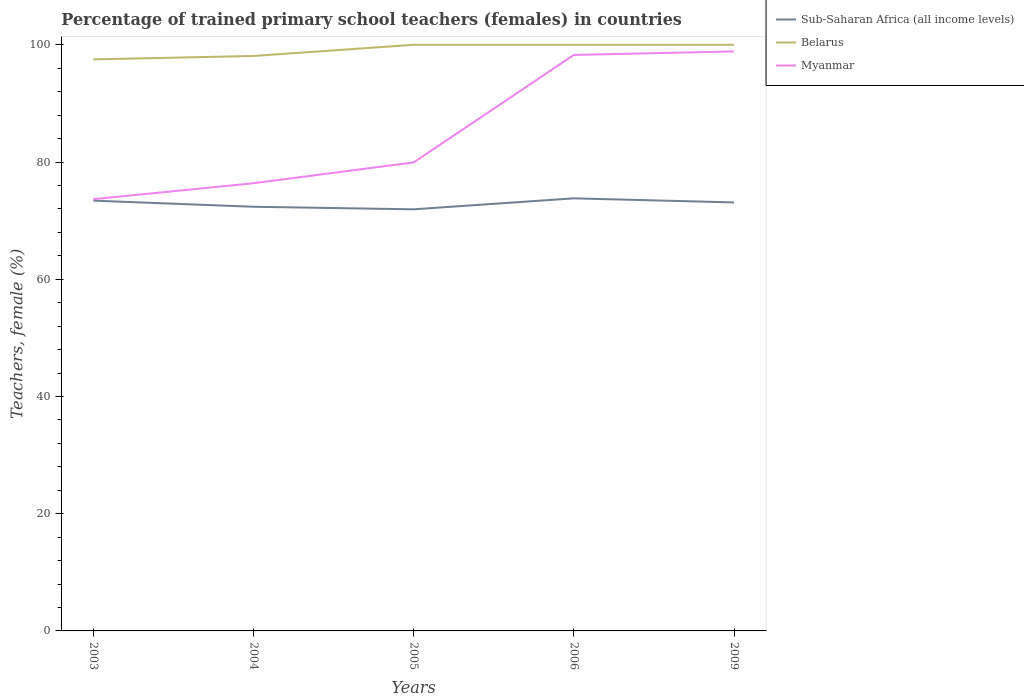How many different coloured lines are there?
Offer a terse response. 3. Is the number of lines equal to the number of legend labels?
Offer a very short reply. Yes. Across all years, what is the maximum percentage of trained primary school teachers (females) in Belarus?
Offer a terse response. 97.51. In which year was the percentage of trained primary school teachers (females) in Myanmar maximum?
Offer a terse response. 2003. What is the total percentage of trained primary school teachers (females) in Sub-Saharan Africa (all income levels) in the graph?
Your answer should be very brief. 1.48. What is the difference between the highest and the second highest percentage of trained primary school teachers (females) in Sub-Saharan Africa (all income levels)?
Your response must be concise. 1.87. What is the difference between the highest and the lowest percentage of trained primary school teachers (females) in Belarus?
Keep it short and to the point. 3. How many years are there in the graph?
Give a very brief answer. 5. What is the difference between two consecutive major ticks on the Y-axis?
Ensure brevity in your answer.  20. Where does the legend appear in the graph?
Keep it short and to the point. Top right. What is the title of the graph?
Keep it short and to the point. Percentage of trained primary school teachers (females) in countries. What is the label or title of the Y-axis?
Keep it short and to the point. Teachers, female (%). What is the Teachers, female (%) of Sub-Saharan Africa (all income levels) in 2003?
Offer a terse response. 73.41. What is the Teachers, female (%) in Belarus in 2003?
Offer a very short reply. 97.51. What is the Teachers, female (%) of Myanmar in 2003?
Offer a very short reply. 73.66. What is the Teachers, female (%) of Sub-Saharan Africa (all income levels) in 2004?
Keep it short and to the point. 72.37. What is the Teachers, female (%) in Belarus in 2004?
Keep it short and to the point. 98.1. What is the Teachers, female (%) of Myanmar in 2004?
Provide a short and direct response. 76.38. What is the Teachers, female (%) in Sub-Saharan Africa (all income levels) in 2005?
Your answer should be compact. 71.93. What is the Teachers, female (%) in Belarus in 2005?
Ensure brevity in your answer.  100. What is the Teachers, female (%) in Myanmar in 2005?
Offer a very short reply. 79.94. What is the Teachers, female (%) in Sub-Saharan Africa (all income levels) in 2006?
Keep it short and to the point. 73.81. What is the Teachers, female (%) in Belarus in 2006?
Give a very brief answer. 100. What is the Teachers, female (%) of Myanmar in 2006?
Keep it short and to the point. 98.27. What is the Teachers, female (%) in Sub-Saharan Africa (all income levels) in 2009?
Offer a terse response. 73.1. What is the Teachers, female (%) of Myanmar in 2009?
Ensure brevity in your answer.  98.87. Across all years, what is the maximum Teachers, female (%) in Sub-Saharan Africa (all income levels)?
Provide a succinct answer. 73.81. Across all years, what is the maximum Teachers, female (%) in Belarus?
Your answer should be compact. 100. Across all years, what is the maximum Teachers, female (%) in Myanmar?
Give a very brief answer. 98.87. Across all years, what is the minimum Teachers, female (%) in Sub-Saharan Africa (all income levels)?
Provide a succinct answer. 71.93. Across all years, what is the minimum Teachers, female (%) in Belarus?
Ensure brevity in your answer.  97.51. Across all years, what is the minimum Teachers, female (%) of Myanmar?
Provide a short and direct response. 73.66. What is the total Teachers, female (%) of Sub-Saharan Africa (all income levels) in the graph?
Give a very brief answer. 364.62. What is the total Teachers, female (%) in Belarus in the graph?
Provide a short and direct response. 495.61. What is the total Teachers, female (%) of Myanmar in the graph?
Make the answer very short. 427.13. What is the difference between the Teachers, female (%) of Sub-Saharan Africa (all income levels) in 2003 and that in 2004?
Provide a short and direct response. 1.05. What is the difference between the Teachers, female (%) of Belarus in 2003 and that in 2004?
Provide a succinct answer. -0.58. What is the difference between the Teachers, female (%) in Myanmar in 2003 and that in 2004?
Provide a short and direct response. -2.72. What is the difference between the Teachers, female (%) in Sub-Saharan Africa (all income levels) in 2003 and that in 2005?
Make the answer very short. 1.48. What is the difference between the Teachers, female (%) in Belarus in 2003 and that in 2005?
Your answer should be very brief. -2.49. What is the difference between the Teachers, female (%) in Myanmar in 2003 and that in 2005?
Give a very brief answer. -6.28. What is the difference between the Teachers, female (%) in Sub-Saharan Africa (all income levels) in 2003 and that in 2006?
Your answer should be very brief. -0.39. What is the difference between the Teachers, female (%) of Belarus in 2003 and that in 2006?
Provide a succinct answer. -2.49. What is the difference between the Teachers, female (%) of Myanmar in 2003 and that in 2006?
Provide a succinct answer. -24.61. What is the difference between the Teachers, female (%) in Sub-Saharan Africa (all income levels) in 2003 and that in 2009?
Make the answer very short. 0.31. What is the difference between the Teachers, female (%) of Belarus in 2003 and that in 2009?
Provide a short and direct response. -2.49. What is the difference between the Teachers, female (%) in Myanmar in 2003 and that in 2009?
Your response must be concise. -25.2. What is the difference between the Teachers, female (%) in Sub-Saharan Africa (all income levels) in 2004 and that in 2005?
Provide a succinct answer. 0.43. What is the difference between the Teachers, female (%) in Belarus in 2004 and that in 2005?
Ensure brevity in your answer.  -1.9. What is the difference between the Teachers, female (%) of Myanmar in 2004 and that in 2005?
Offer a terse response. -3.56. What is the difference between the Teachers, female (%) in Sub-Saharan Africa (all income levels) in 2004 and that in 2006?
Ensure brevity in your answer.  -1.44. What is the difference between the Teachers, female (%) of Belarus in 2004 and that in 2006?
Provide a succinct answer. -1.9. What is the difference between the Teachers, female (%) of Myanmar in 2004 and that in 2006?
Your answer should be compact. -21.89. What is the difference between the Teachers, female (%) in Sub-Saharan Africa (all income levels) in 2004 and that in 2009?
Your answer should be very brief. -0.74. What is the difference between the Teachers, female (%) in Belarus in 2004 and that in 2009?
Provide a short and direct response. -1.9. What is the difference between the Teachers, female (%) in Myanmar in 2004 and that in 2009?
Provide a short and direct response. -22.49. What is the difference between the Teachers, female (%) in Sub-Saharan Africa (all income levels) in 2005 and that in 2006?
Make the answer very short. -1.87. What is the difference between the Teachers, female (%) of Belarus in 2005 and that in 2006?
Keep it short and to the point. 0. What is the difference between the Teachers, female (%) in Myanmar in 2005 and that in 2006?
Give a very brief answer. -18.33. What is the difference between the Teachers, female (%) of Sub-Saharan Africa (all income levels) in 2005 and that in 2009?
Provide a succinct answer. -1.17. What is the difference between the Teachers, female (%) of Belarus in 2005 and that in 2009?
Your response must be concise. 0. What is the difference between the Teachers, female (%) of Myanmar in 2005 and that in 2009?
Provide a succinct answer. -18.93. What is the difference between the Teachers, female (%) of Sub-Saharan Africa (all income levels) in 2006 and that in 2009?
Your response must be concise. 0.7. What is the difference between the Teachers, female (%) of Myanmar in 2006 and that in 2009?
Provide a succinct answer. -0.6. What is the difference between the Teachers, female (%) of Sub-Saharan Africa (all income levels) in 2003 and the Teachers, female (%) of Belarus in 2004?
Make the answer very short. -24.68. What is the difference between the Teachers, female (%) of Sub-Saharan Africa (all income levels) in 2003 and the Teachers, female (%) of Myanmar in 2004?
Your response must be concise. -2.97. What is the difference between the Teachers, female (%) of Belarus in 2003 and the Teachers, female (%) of Myanmar in 2004?
Offer a terse response. 21.13. What is the difference between the Teachers, female (%) in Sub-Saharan Africa (all income levels) in 2003 and the Teachers, female (%) in Belarus in 2005?
Provide a succinct answer. -26.59. What is the difference between the Teachers, female (%) of Sub-Saharan Africa (all income levels) in 2003 and the Teachers, female (%) of Myanmar in 2005?
Provide a succinct answer. -6.53. What is the difference between the Teachers, female (%) of Belarus in 2003 and the Teachers, female (%) of Myanmar in 2005?
Provide a short and direct response. 17.57. What is the difference between the Teachers, female (%) of Sub-Saharan Africa (all income levels) in 2003 and the Teachers, female (%) of Belarus in 2006?
Make the answer very short. -26.59. What is the difference between the Teachers, female (%) in Sub-Saharan Africa (all income levels) in 2003 and the Teachers, female (%) in Myanmar in 2006?
Offer a terse response. -24.86. What is the difference between the Teachers, female (%) of Belarus in 2003 and the Teachers, female (%) of Myanmar in 2006?
Your response must be concise. -0.76. What is the difference between the Teachers, female (%) of Sub-Saharan Africa (all income levels) in 2003 and the Teachers, female (%) of Belarus in 2009?
Provide a short and direct response. -26.59. What is the difference between the Teachers, female (%) of Sub-Saharan Africa (all income levels) in 2003 and the Teachers, female (%) of Myanmar in 2009?
Your answer should be very brief. -25.46. What is the difference between the Teachers, female (%) in Belarus in 2003 and the Teachers, female (%) in Myanmar in 2009?
Keep it short and to the point. -1.36. What is the difference between the Teachers, female (%) of Sub-Saharan Africa (all income levels) in 2004 and the Teachers, female (%) of Belarus in 2005?
Your response must be concise. -27.63. What is the difference between the Teachers, female (%) in Sub-Saharan Africa (all income levels) in 2004 and the Teachers, female (%) in Myanmar in 2005?
Your answer should be compact. -7.57. What is the difference between the Teachers, female (%) in Belarus in 2004 and the Teachers, female (%) in Myanmar in 2005?
Offer a terse response. 18.16. What is the difference between the Teachers, female (%) of Sub-Saharan Africa (all income levels) in 2004 and the Teachers, female (%) of Belarus in 2006?
Your response must be concise. -27.63. What is the difference between the Teachers, female (%) in Sub-Saharan Africa (all income levels) in 2004 and the Teachers, female (%) in Myanmar in 2006?
Your answer should be very brief. -25.91. What is the difference between the Teachers, female (%) of Belarus in 2004 and the Teachers, female (%) of Myanmar in 2006?
Your response must be concise. -0.18. What is the difference between the Teachers, female (%) of Sub-Saharan Africa (all income levels) in 2004 and the Teachers, female (%) of Belarus in 2009?
Your answer should be very brief. -27.63. What is the difference between the Teachers, female (%) in Sub-Saharan Africa (all income levels) in 2004 and the Teachers, female (%) in Myanmar in 2009?
Offer a very short reply. -26.5. What is the difference between the Teachers, female (%) of Belarus in 2004 and the Teachers, female (%) of Myanmar in 2009?
Your answer should be very brief. -0.77. What is the difference between the Teachers, female (%) in Sub-Saharan Africa (all income levels) in 2005 and the Teachers, female (%) in Belarus in 2006?
Make the answer very short. -28.07. What is the difference between the Teachers, female (%) of Sub-Saharan Africa (all income levels) in 2005 and the Teachers, female (%) of Myanmar in 2006?
Your answer should be compact. -26.34. What is the difference between the Teachers, female (%) of Belarus in 2005 and the Teachers, female (%) of Myanmar in 2006?
Make the answer very short. 1.73. What is the difference between the Teachers, female (%) in Sub-Saharan Africa (all income levels) in 2005 and the Teachers, female (%) in Belarus in 2009?
Offer a very short reply. -28.07. What is the difference between the Teachers, female (%) in Sub-Saharan Africa (all income levels) in 2005 and the Teachers, female (%) in Myanmar in 2009?
Offer a very short reply. -26.94. What is the difference between the Teachers, female (%) of Belarus in 2005 and the Teachers, female (%) of Myanmar in 2009?
Provide a succinct answer. 1.13. What is the difference between the Teachers, female (%) in Sub-Saharan Africa (all income levels) in 2006 and the Teachers, female (%) in Belarus in 2009?
Give a very brief answer. -26.19. What is the difference between the Teachers, female (%) of Sub-Saharan Africa (all income levels) in 2006 and the Teachers, female (%) of Myanmar in 2009?
Keep it short and to the point. -25.06. What is the difference between the Teachers, female (%) of Belarus in 2006 and the Teachers, female (%) of Myanmar in 2009?
Provide a short and direct response. 1.13. What is the average Teachers, female (%) in Sub-Saharan Africa (all income levels) per year?
Keep it short and to the point. 72.92. What is the average Teachers, female (%) in Belarus per year?
Your response must be concise. 99.12. What is the average Teachers, female (%) in Myanmar per year?
Make the answer very short. 85.43. In the year 2003, what is the difference between the Teachers, female (%) of Sub-Saharan Africa (all income levels) and Teachers, female (%) of Belarus?
Provide a short and direct response. -24.1. In the year 2003, what is the difference between the Teachers, female (%) of Sub-Saharan Africa (all income levels) and Teachers, female (%) of Myanmar?
Keep it short and to the point. -0.25. In the year 2003, what is the difference between the Teachers, female (%) in Belarus and Teachers, female (%) in Myanmar?
Your response must be concise. 23.85. In the year 2004, what is the difference between the Teachers, female (%) in Sub-Saharan Africa (all income levels) and Teachers, female (%) in Belarus?
Ensure brevity in your answer.  -25.73. In the year 2004, what is the difference between the Teachers, female (%) in Sub-Saharan Africa (all income levels) and Teachers, female (%) in Myanmar?
Your answer should be very brief. -4.02. In the year 2004, what is the difference between the Teachers, female (%) of Belarus and Teachers, female (%) of Myanmar?
Give a very brief answer. 21.71. In the year 2005, what is the difference between the Teachers, female (%) in Sub-Saharan Africa (all income levels) and Teachers, female (%) in Belarus?
Provide a succinct answer. -28.07. In the year 2005, what is the difference between the Teachers, female (%) in Sub-Saharan Africa (all income levels) and Teachers, female (%) in Myanmar?
Offer a very short reply. -8.01. In the year 2005, what is the difference between the Teachers, female (%) of Belarus and Teachers, female (%) of Myanmar?
Your answer should be very brief. 20.06. In the year 2006, what is the difference between the Teachers, female (%) in Sub-Saharan Africa (all income levels) and Teachers, female (%) in Belarus?
Your answer should be very brief. -26.19. In the year 2006, what is the difference between the Teachers, female (%) of Sub-Saharan Africa (all income levels) and Teachers, female (%) of Myanmar?
Provide a short and direct response. -24.47. In the year 2006, what is the difference between the Teachers, female (%) in Belarus and Teachers, female (%) in Myanmar?
Your answer should be very brief. 1.73. In the year 2009, what is the difference between the Teachers, female (%) in Sub-Saharan Africa (all income levels) and Teachers, female (%) in Belarus?
Your answer should be very brief. -26.9. In the year 2009, what is the difference between the Teachers, female (%) of Sub-Saharan Africa (all income levels) and Teachers, female (%) of Myanmar?
Provide a short and direct response. -25.76. In the year 2009, what is the difference between the Teachers, female (%) of Belarus and Teachers, female (%) of Myanmar?
Provide a short and direct response. 1.13. What is the ratio of the Teachers, female (%) of Sub-Saharan Africa (all income levels) in 2003 to that in 2004?
Ensure brevity in your answer.  1.01. What is the ratio of the Teachers, female (%) in Belarus in 2003 to that in 2004?
Make the answer very short. 0.99. What is the ratio of the Teachers, female (%) of Myanmar in 2003 to that in 2004?
Offer a very short reply. 0.96. What is the ratio of the Teachers, female (%) of Sub-Saharan Africa (all income levels) in 2003 to that in 2005?
Offer a very short reply. 1.02. What is the ratio of the Teachers, female (%) of Belarus in 2003 to that in 2005?
Ensure brevity in your answer.  0.98. What is the ratio of the Teachers, female (%) of Myanmar in 2003 to that in 2005?
Provide a succinct answer. 0.92. What is the ratio of the Teachers, female (%) in Sub-Saharan Africa (all income levels) in 2003 to that in 2006?
Your response must be concise. 0.99. What is the ratio of the Teachers, female (%) of Belarus in 2003 to that in 2006?
Your response must be concise. 0.98. What is the ratio of the Teachers, female (%) of Myanmar in 2003 to that in 2006?
Your answer should be compact. 0.75. What is the ratio of the Teachers, female (%) of Belarus in 2003 to that in 2009?
Make the answer very short. 0.98. What is the ratio of the Teachers, female (%) in Myanmar in 2003 to that in 2009?
Your answer should be compact. 0.75. What is the ratio of the Teachers, female (%) in Sub-Saharan Africa (all income levels) in 2004 to that in 2005?
Offer a very short reply. 1.01. What is the ratio of the Teachers, female (%) in Myanmar in 2004 to that in 2005?
Your answer should be very brief. 0.96. What is the ratio of the Teachers, female (%) of Sub-Saharan Africa (all income levels) in 2004 to that in 2006?
Offer a terse response. 0.98. What is the ratio of the Teachers, female (%) in Belarus in 2004 to that in 2006?
Your answer should be very brief. 0.98. What is the ratio of the Teachers, female (%) of Myanmar in 2004 to that in 2006?
Keep it short and to the point. 0.78. What is the ratio of the Teachers, female (%) in Belarus in 2004 to that in 2009?
Give a very brief answer. 0.98. What is the ratio of the Teachers, female (%) in Myanmar in 2004 to that in 2009?
Offer a very short reply. 0.77. What is the ratio of the Teachers, female (%) in Sub-Saharan Africa (all income levels) in 2005 to that in 2006?
Keep it short and to the point. 0.97. What is the ratio of the Teachers, female (%) in Belarus in 2005 to that in 2006?
Ensure brevity in your answer.  1. What is the ratio of the Teachers, female (%) in Myanmar in 2005 to that in 2006?
Your response must be concise. 0.81. What is the ratio of the Teachers, female (%) in Myanmar in 2005 to that in 2009?
Offer a terse response. 0.81. What is the ratio of the Teachers, female (%) of Sub-Saharan Africa (all income levels) in 2006 to that in 2009?
Make the answer very short. 1.01. What is the ratio of the Teachers, female (%) in Myanmar in 2006 to that in 2009?
Provide a succinct answer. 0.99. What is the difference between the highest and the second highest Teachers, female (%) of Sub-Saharan Africa (all income levels)?
Your answer should be compact. 0.39. What is the difference between the highest and the second highest Teachers, female (%) in Myanmar?
Keep it short and to the point. 0.6. What is the difference between the highest and the lowest Teachers, female (%) in Sub-Saharan Africa (all income levels)?
Your answer should be very brief. 1.87. What is the difference between the highest and the lowest Teachers, female (%) in Belarus?
Offer a terse response. 2.49. What is the difference between the highest and the lowest Teachers, female (%) of Myanmar?
Offer a terse response. 25.2. 